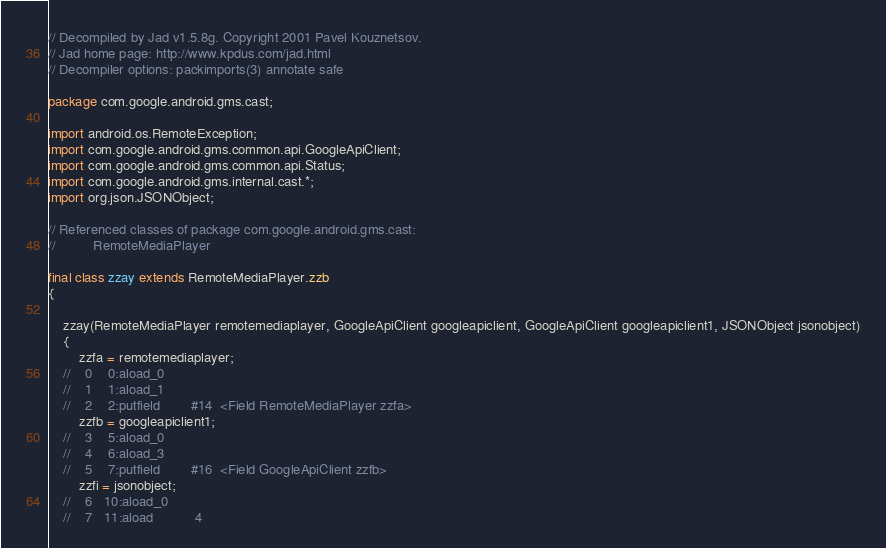Convert code to text. <code><loc_0><loc_0><loc_500><loc_500><_Java_>// Decompiled by Jad v1.5.8g. Copyright 2001 Pavel Kouznetsov.
// Jad home page: http://www.kpdus.com/jad.html
// Decompiler options: packimports(3) annotate safe 

package com.google.android.gms.cast;

import android.os.RemoteException;
import com.google.android.gms.common.api.GoogleApiClient;
import com.google.android.gms.common.api.Status;
import com.google.android.gms.internal.cast.*;
import org.json.JSONObject;

// Referenced classes of package com.google.android.gms.cast:
//			RemoteMediaPlayer

final class zzay extends RemoteMediaPlayer.zzb
{

	zzay(RemoteMediaPlayer remotemediaplayer, GoogleApiClient googleapiclient, GoogleApiClient googleapiclient1, JSONObject jsonobject)
	{
		zzfa = remotemediaplayer;
	//    0    0:aload_0         
	//    1    1:aload_1         
	//    2    2:putfield        #14  <Field RemoteMediaPlayer zzfa>
		zzfb = googleapiclient1;
	//    3    5:aload_0         
	//    4    6:aload_3         
	//    5    7:putfield        #16  <Field GoogleApiClient zzfb>
		zzfi = jsonobject;
	//    6   10:aload_0         
	//    7   11:aload           4</code> 